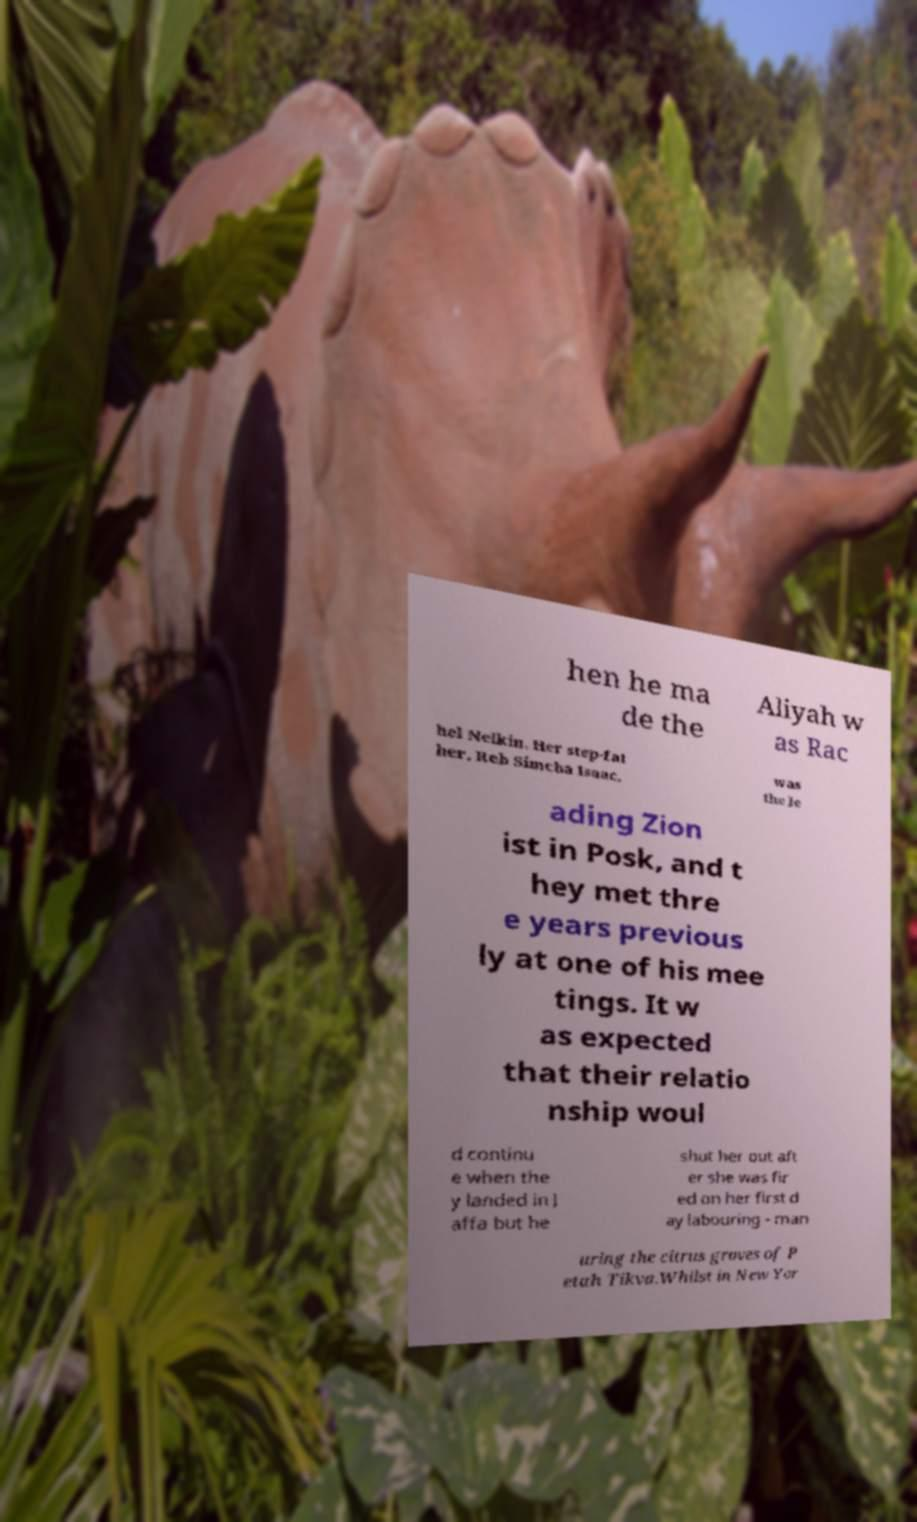Could you assist in decoding the text presented in this image and type it out clearly? hen he ma de the Aliyah w as Rac hel Nelkin. Her step-fat her, Reb Simcha Isaac, was the le ading Zion ist in Posk, and t hey met thre e years previous ly at one of his mee tings. It w as expected that their relatio nship woul d continu e when the y landed in J affa but he shut her out aft er she was fir ed on her first d ay labouring - man uring the citrus groves of P etah Tikva.Whilst in New Yor 